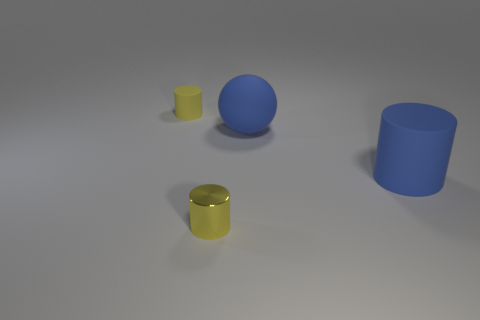There is a rubber cylinder in front of the small yellow cylinder behind the rubber cylinder that is to the right of the tiny yellow shiny object; what is its size?
Ensure brevity in your answer.  Large. Are there any cylinders that have the same color as the big rubber ball?
Ensure brevity in your answer.  Yes. How many spheres are there?
Offer a very short reply. 1. What is the tiny object behind the tiny object in front of the rubber thing behind the ball made of?
Your response must be concise. Rubber. Is there a yellow object that has the same material as the large cylinder?
Give a very brief answer. Yes. How many cubes are metal objects or blue rubber objects?
Provide a succinct answer. 0. There is a ball that is the same material as the big blue cylinder; what is its color?
Your answer should be compact. Blue. Are there fewer small shiny things than small green metal cylinders?
Provide a short and direct response. No. There is a object that is right of the large matte ball; is its shape the same as the blue rubber object that is behind the large rubber cylinder?
Your answer should be compact. No. How many objects are matte spheres or yellow objects?
Provide a succinct answer. 3. 